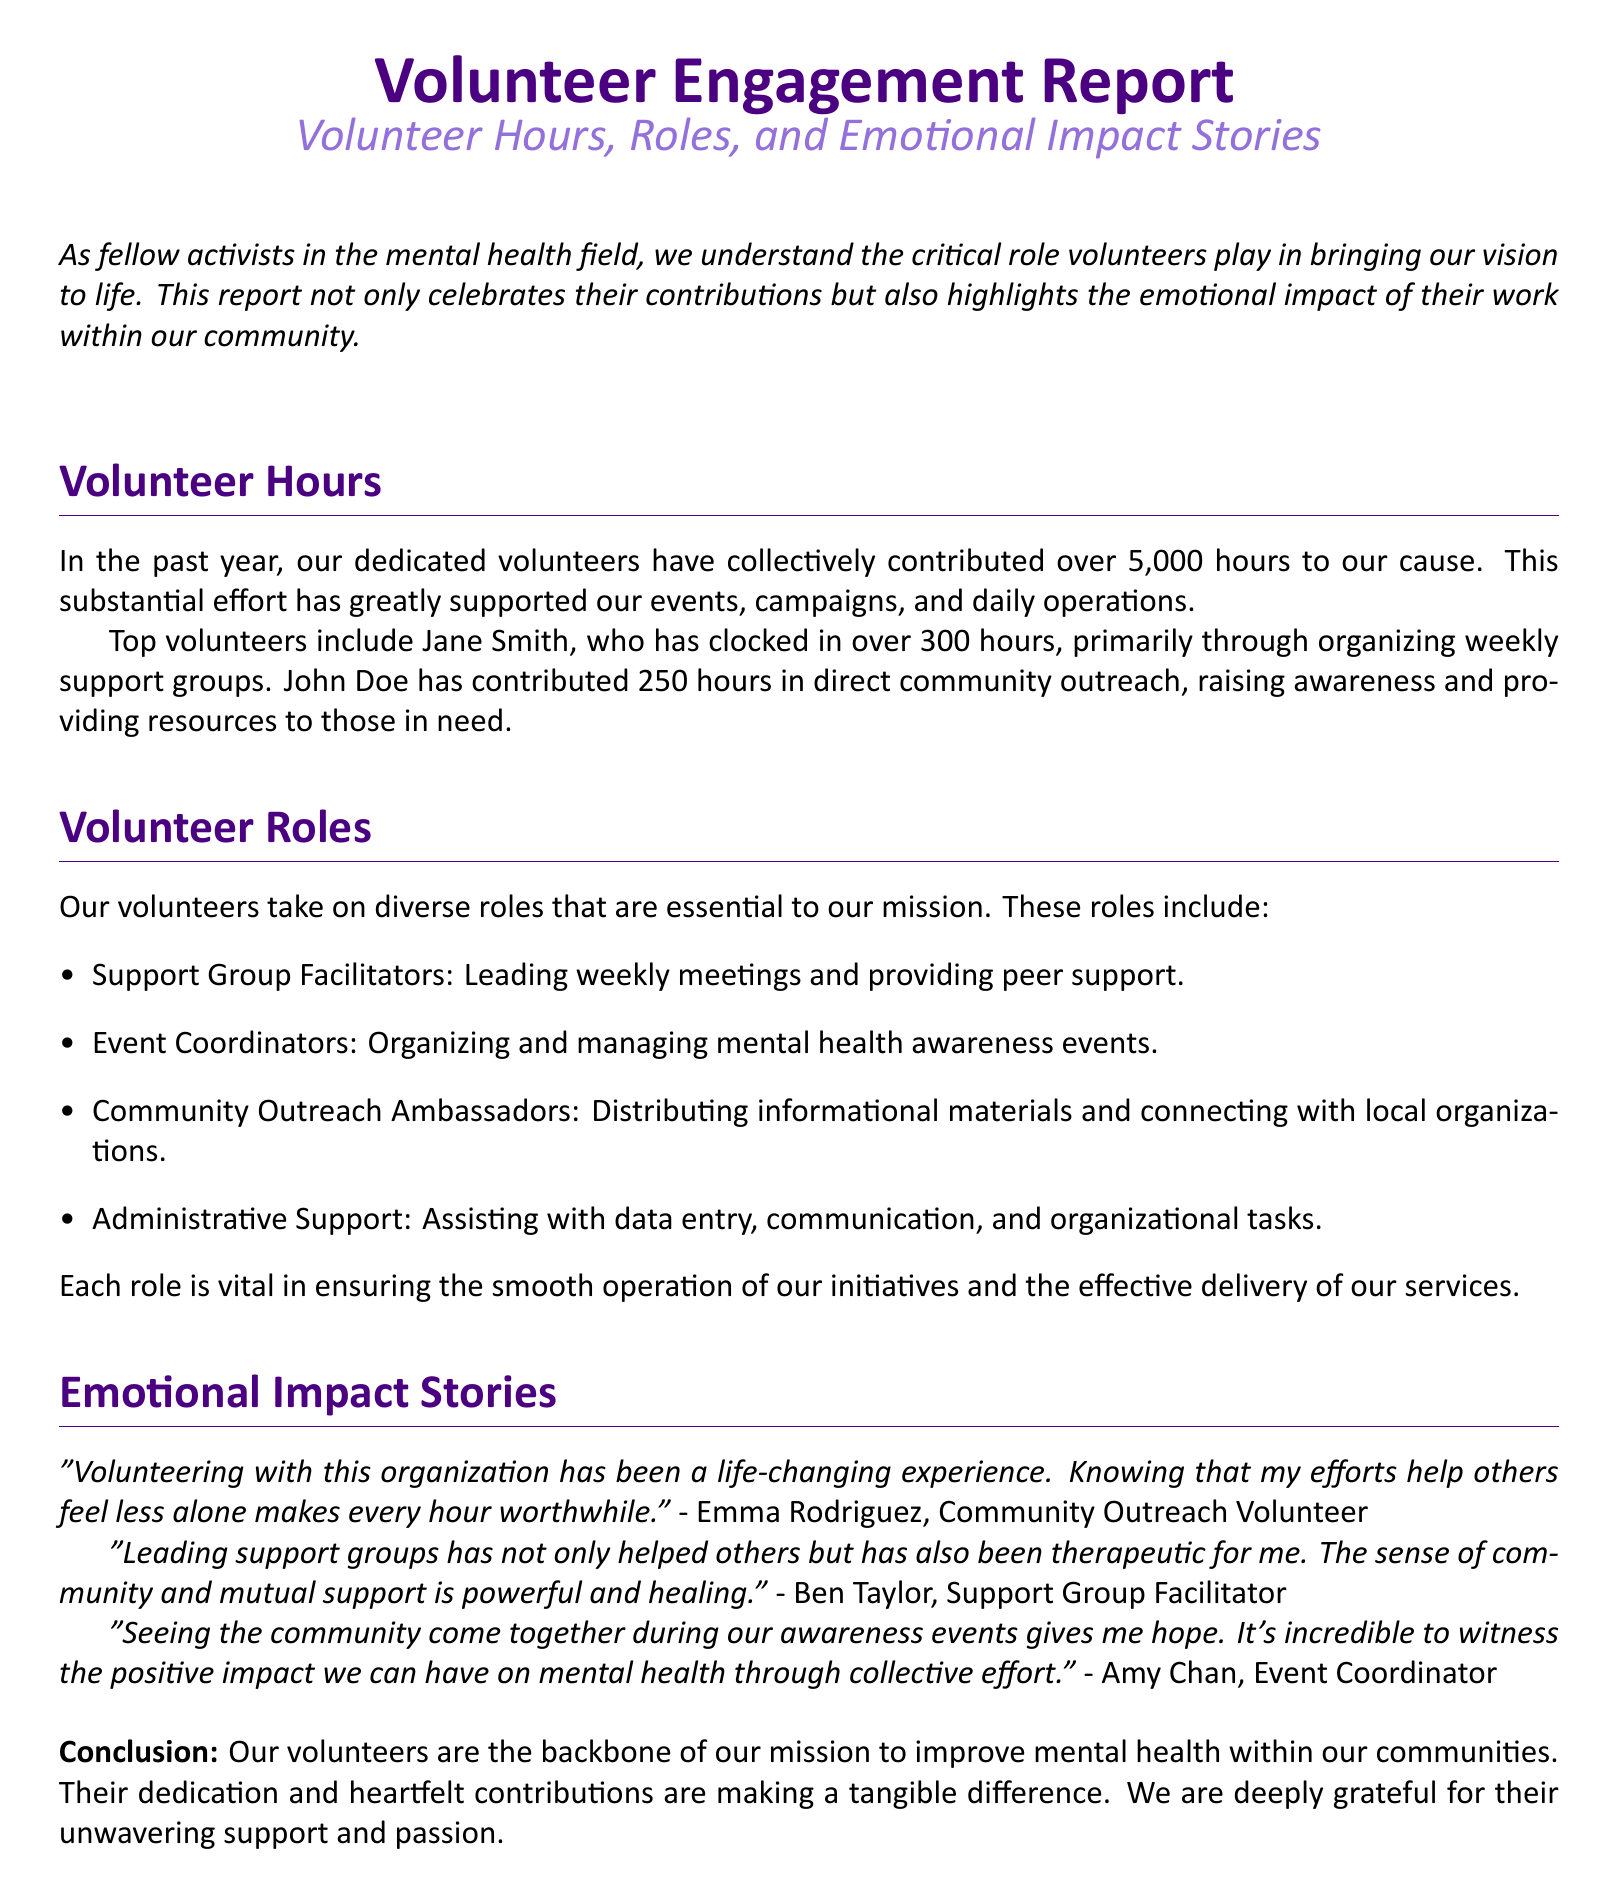What is the total number of volunteer hours contributed? The total number of volunteer hours is mentioned in the document, which states that over 5,000 hours have been contributed by volunteers.
Answer: over 5,000 hours Who is the top volunteer by hours? The document lists Jane Smith as the top volunteer with over 300 hours contributed primarily through organizing weekly support groups.
Answer: Jane Smith How many hours did John Doe contribute? The document specifies that John Doe has contributed 250 hours in direct community outreach.
Answer: 250 hours What role do Support Group Facilitators play? The document outlines the role of Support Group Facilitators, indicating they lead weekly meetings and provide peer support.
Answer: Leading weekly meetings and providing peer support What is the emotional impact of volunteering according to Emma Rodriguez? Emma Rodriguez describes her volunteering experience as life-changing and emphasizes the importance of her efforts in helping others feel less alone.
Answer: Life-changing experience How many volunteers are mentioned in the emotional impact stories? The document includes emotional impact stories from three different volunteers, each sharing their personal experiences regarding volunteering.
Answer: Three What color is used for the section titles? The document specifies that the section titles are colored in the main color defined at the beginning of the document.
Answer: maincolor Who organized the mental health awareness events? According to the document, Amy Chan serves as the Event Coordinator responsible for organizing and managing mental health awareness events.
Answer: Amy Chan 